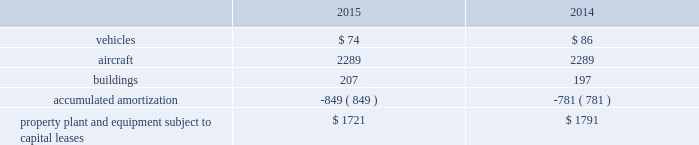United parcel service , inc .
And subsidiaries notes to consolidated financial statements capital lease obligations we have certain property , plant and equipment subject to capital leases .
Some of the obligations associated with these capital leases have been legally defeased .
The recorded value of our property , plant and equipment subject to capital leases is as follows as of december 31 ( in millions ) : .
These capital lease obligations have principal payments due at various dates from 2016 through 3005 .
Facility notes and bonds we have entered into agreements with certain municipalities to finance the construction of , or improvements to , facilities that support our u.s .
Domestic package and supply chain & freight operations in the united states .
These facilities are located around airport properties in louisville , kentucky ; dallas , texas ; and philadelphia , pennsylvania .
Under these arrangements , we enter into a lease or loan agreement that covers the debt service obligations on the bonds issued by the municipalities , as follows : 2022 bonds with a principal balance of $ 149 million issued by the louisville regional airport authority associated with our worldport facility in louisville , kentucky .
The bonds , which are due in january 2029 , bear interest at a variable rate , and the average interest rates for 2015 and 2014 were 0.03% ( 0.03 % ) and 0.05% ( 0.05 % ) , respectively .
2022 bonds with a principal balance of $ 42 million and due in november 2036 issued by the louisville regional airport authority associated with our air freight facility in louisville , kentucky .
The bonds bear interest at a variable rate , and the average interest rates for 2015 and 2014 were 0.02% ( 0.02 % ) and 0.05% ( 0.05 % ) , respectively .
2022 bonds with a principal balance of $ 29 million issued by the dallas / fort worth international airport facility improvement corporation associated with our dallas , texas airport facilities .
The bonds are due in may 2032 and bear interest at a variable rate , however the variable cash flows on the obligation have been swapped to a fixed 5.11% ( 5.11 % ) .
2022 bonds with a principal balance of $ 100 million issued by the delaware county , pennsylvania industrial development authority associated with our philadelphia , pennsylvania airport facilities .
The bonds , which were due in december 2015 , had a variable interest rate , and the average interest rates for 2015 and 2014 were 0.02% ( 0.02 % ) and 0.04% ( 0.04 % ) , respectively .
As of december 2015 , these $ 100 million bonds were repaid in full .
2022 in september 2015 , we entered into an agreement with the delaware county , pennsylvania industrial development authority , associated with our philadelphia , pennsylvania airport facilities , for bonds issued with a principal balance of $ 100 million .
These bonds , which are due september 2045 , bear interest at a variable rate .
The average interest rate for 2015 was 0.00% ( 0.00 % ) .
Pound sterling notes the pound sterling notes consist of two separate tranches , as follows : 2022 notes with a principal amount of a366 million accrue interest at a 5.50% ( 5.50 % ) fixed rate , and are due in february 2031 .
These notes are not callable .
2022 notes with a principal amount of a3455 million accrue interest at a 5.125% ( 5.125 % ) fixed rate , and are due in february 2050 .
These notes are callable at our option at a redemption price equal to the greater of 100% ( 100 % ) of the principal amount and accrued interest , or the sum of the present values of the remaining scheduled payout of principal and interest thereon discounted to the date of redemption at a benchmark u.k .
Government bond yield plus 15 basis points and accrued interest. .
What is the difference in total property , plant and equipment subject to capital lease between 2014 and 2015? 
Computations: (1721 - 1791)
Answer: -70.0. United parcel service , inc .
And subsidiaries notes to consolidated financial statements capital lease obligations we have certain property , plant and equipment subject to capital leases .
Some of the obligations associated with these capital leases have been legally defeased .
The recorded value of our property , plant and equipment subject to capital leases is as follows as of december 31 ( in millions ) : .
These capital lease obligations have principal payments due at various dates from 2016 through 3005 .
Facility notes and bonds we have entered into agreements with certain municipalities to finance the construction of , or improvements to , facilities that support our u.s .
Domestic package and supply chain & freight operations in the united states .
These facilities are located around airport properties in louisville , kentucky ; dallas , texas ; and philadelphia , pennsylvania .
Under these arrangements , we enter into a lease or loan agreement that covers the debt service obligations on the bonds issued by the municipalities , as follows : 2022 bonds with a principal balance of $ 149 million issued by the louisville regional airport authority associated with our worldport facility in louisville , kentucky .
The bonds , which are due in january 2029 , bear interest at a variable rate , and the average interest rates for 2015 and 2014 were 0.03% ( 0.03 % ) and 0.05% ( 0.05 % ) , respectively .
2022 bonds with a principal balance of $ 42 million and due in november 2036 issued by the louisville regional airport authority associated with our air freight facility in louisville , kentucky .
The bonds bear interest at a variable rate , and the average interest rates for 2015 and 2014 were 0.02% ( 0.02 % ) and 0.05% ( 0.05 % ) , respectively .
2022 bonds with a principal balance of $ 29 million issued by the dallas / fort worth international airport facility improvement corporation associated with our dallas , texas airport facilities .
The bonds are due in may 2032 and bear interest at a variable rate , however the variable cash flows on the obligation have been swapped to a fixed 5.11% ( 5.11 % ) .
2022 bonds with a principal balance of $ 100 million issued by the delaware county , pennsylvania industrial development authority associated with our philadelphia , pennsylvania airport facilities .
The bonds , which were due in december 2015 , had a variable interest rate , and the average interest rates for 2015 and 2014 were 0.02% ( 0.02 % ) and 0.04% ( 0.04 % ) , respectively .
As of december 2015 , these $ 100 million bonds were repaid in full .
2022 in september 2015 , we entered into an agreement with the delaware county , pennsylvania industrial development authority , associated with our philadelphia , pennsylvania airport facilities , for bonds issued with a principal balance of $ 100 million .
These bonds , which are due september 2045 , bear interest at a variable rate .
The average interest rate for 2015 was 0.00% ( 0.00 % ) .
Pound sterling notes the pound sterling notes consist of two separate tranches , as follows : 2022 notes with a principal amount of a366 million accrue interest at a 5.50% ( 5.50 % ) fixed rate , and are due in february 2031 .
These notes are not callable .
2022 notes with a principal amount of a3455 million accrue interest at a 5.125% ( 5.125 % ) fixed rate , and are due in february 2050 .
These notes are callable at our option at a redemption price equal to the greater of 100% ( 100 % ) of the principal amount and accrued interest , or the sum of the present values of the remaining scheduled payout of principal and interest thereon discounted to the date of redemption at a benchmark u.k .
Government bond yield plus 15 basis points and accrued interest. .
What was the change in millions of aircraft from 2014 to 2015? 
Computations: (2289 - 2289)
Answer: 0.0. 